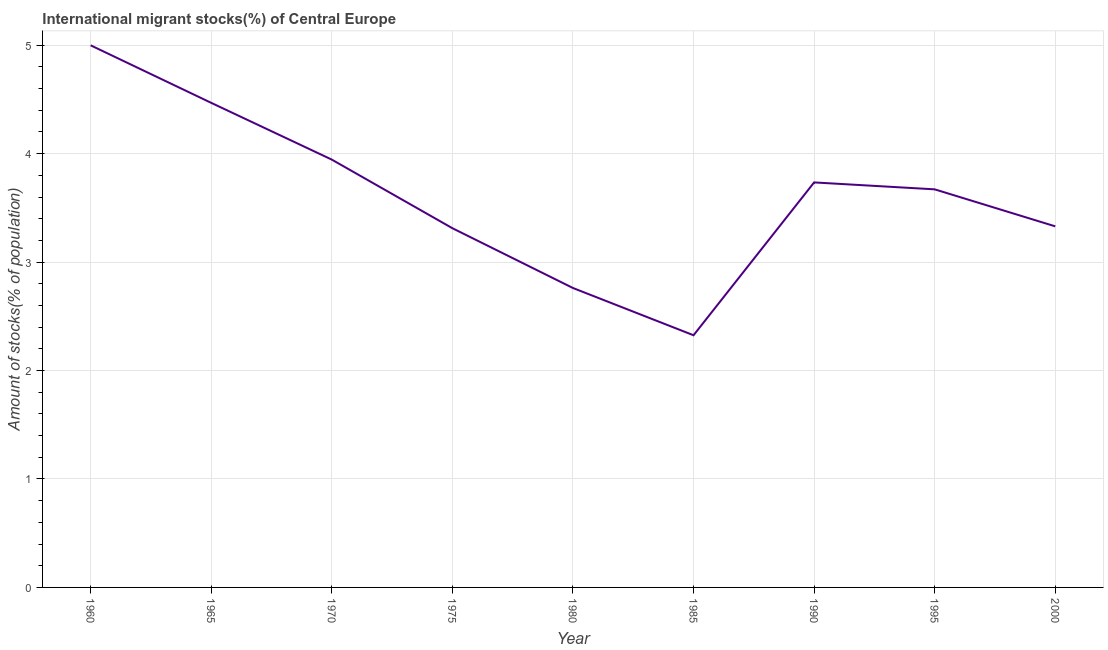What is the number of international migrant stocks in 1970?
Offer a very short reply. 3.95. Across all years, what is the maximum number of international migrant stocks?
Give a very brief answer. 5. Across all years, what is the minimum number of international migrant stocks?
Ensure brevity in your answer.  2.33. In which year was the number of international migrant stocks maximum?
Provide a short and direct response. 1960. What is the sum of the number of international migrant stocks?
Offer a terse response. 32.55. What is the difference between the number of international migrant stocks in 1980 and 1995?
Your answer should be compact. -0.91. What is the average number of international migrant stocks per year?
Keep it short and to the point. 3.62. What is the median number of international migrant stocks?
Offer a terse response. 3.67. In how many years, is the number of international migrant stocks greater than 0.2 %?
Your answer should be compact. 9. Do a majority of the years between 2000 and 1970 (inclusive) have number of international migrant stocks greater than 3.8 %?
Your answer should be compact. Yes. What is the ratio of the number of international migrant stocks in 1980 to that in 1995?
Provide a succinct answer. 0.75. What is the difference between the highest and the second highest number of international migrant stocks?
Ensure brevity in your answer.  0.53. Is the sum of the number of international migrant stocks in 1965 and 1995 greater than the maximum number of international migrant stocks across all years?
Offer a terse response. Yes. What is the difference between the highest and the lowest number of international migrant stocks?
Your response must be concise. 2.67. Does the number of international migrant stocks monotonically increase over the years?
Ensure brevity in your answer.  No. How many lines are there?
Offer a terse response. 1. How many years are there in the graph?
Your answer should be compact. 9. What is the difference between two consecutive major ticks on the Y-axis?
Provide a succinct answer. 1. Are the values on the major ticks of Y-axis written in scientific E-notation?
Give a very brief answer. No. Does the graph contain any zero values?
Provide a succinct answer. No. What is the title of the graph?
Offer a terse response. International migrant stocks(%) of Central Europe. What is the label or title of the X-axis?
Keep it short and to the point. Year. What is the label or title of the Y-axis?
Make the answer very short. Amount of stocks(% of population). What is the Amount of stocks(% of population) of 1960?
Keep it short and to the point. 5. What is the Amount of stocks(% of population) in 1965?
Give a very brief answer. 4.47. What is the Amount of stocks(% of population) in 1970?
Ensure brevity in your answer.  3.95. What is the Amount of stocks(% of population) in 1975?
Your answer should be compact. 3.31. What is the Amount of stocks(% of population) in 1980?
Offer a terse response. 2.76. What is the Amount of stocks(% of population) in 1985?
Offer a very short reply. 2.33. What is the Amount of stocks(% of population) of 1990?
Offer a terse response. 3.73. What is the Amount of stocks(% of population) in 1995?
Your answer should be very brief. 3.67. What is the Amount of stocks(% of population) in 2000?
Keep it short and to the point. 3.33. What is the difference between the Amount of stocks(% of population) in 1960 and 1965?
Offer a terse response. 0.53. What is the difference between the Amount of stocks(% of population) in 1960 and 1970?
Ensure brevity in your answer.  1.05. What is the difference between the Amount of stocks(% of population) in 1960 and 1975?
Your response must be concise. 1.69. What is the difference between the Amount of stocks(% of population) in 1960 and 1980?
Provide a succinct answer. 2.24. What is the difference between the Amount of stocks(% of population) in 1960 and 1985?
Provide a short and direct response. 2.67. What is the difference between the Amount of stocks(% of population) in 1960 and 1990?
Provide a succinct answer. 1.26. What is the difference between the Amount of stocks(% of population) in 1960 and 1995?
Your answer should be very brief. 1.33. What is the difference between the Amount of stocks(% of population) in 1960 and 2000?
Give a very brief answer. 1.67. What is the difference between the Amount of stocks(% of population) in 1965 and 1970?
Offer a very short reply. 0.52. What is the difference between the Amount of stocks(% of population) in 1965 and 1975?
Offer a very short reply. 1.16. What is the difference between the Amount of stocks(% of population) in 1965 and 1980?
Your response must be concise. 1.71. What is the difference between the Amount of stocks(% of population) in 1965 and 1985?
Offer a very short reply. 2.14. What is the difference between the Amount of stocks(% of population) in 1965 and 1990?
Your response must be concise. 0.73. What is the difference between the Amount of stocks(% of population) in 1965 and 1995?
Provide a short and direct response. 0.8. What is the difference between the Amount of stocks(% of population) in 1965 and 2000?
Offer a very short reply. 1.14. What is the difference between the Amount of stocks(% of population) in 1970 and 1975?
Offer a very short reply. 0.63. What is the difference between the Amount of stocks(% of population) in 1970 and 1980?
Make the answer very short. 1.18. What is the difference between the Amount of stocks(% of population) in 1970 and 1985?
Your answer should be compact. 1.62. What is the difference between the Amount of stocks(% of population) in 1970 and 1990?
Your answer should be very brief. 0.21. What is the difference between the Amount of stocks(% of population) in 1970 and 1995?
Your answer should be very brief. 0.27. What is the difference between the Amount of stocks(% of population) in 1970 and 2000?
Your response must be concise. 0.62. What is the difference between the Amount of stocks(% of population) in 1975 and 1980?
Your answer should be very brief. 0.55. What is the difference between the Amount of stocks(% of population) in 1975 and 1985?
Provide a succinct answer. 0.99. What is the difference between the Amount of stocks(% of population) in 1975 and 1990?
Offer a very short reply. -0.42. What is the difference between the Amount of stocks(% of population) in 1975 and 1995?
Give a very brief answer. -0.36. What is the difference between the Amount of stocks(% of population) in 1975 and 2000?
Your response must be concise. -0.02. What is the difference between the Amount of stocks(% of population) in 1980 and 1985?
Your answer should be very brief. 0.44. What is the difference between the Amount of stocks(% of population) in 1980 and 1990?
Your answer should be compact. -0.97. What is the difference between the Amount of stocks(% of population) in 1980 and 1995?
Offer a very short reply. -0.91. What is the difference between the Amount of stocks(% of population) in 1980 and 2000?
Ensure brevity in your answer.  -0.57. What is the difference between the Amount of stocks(% of population) in 1985 and 1990?
Ensure brevity in your answer.  -1.41. What is the difference between the Amount of stocks(% of population) in 1985 and 1995?
Provide a succinct answer. -1.35. What is the difference between the Amount of stocks(% of population) in 1985 and 2000?
Your answer should be very brief. -1. What is the difference between the Amount of stocks(% of population) in 1990 and 1995?
Offer a terse response. 0.06. What is the difference between the Amount of stocks(% of population) in 1990 and 2000?
Your answer should be compact. 0.41. What is the difference between the Amount of stocks(% of population) in 1995 and 2000?
Your answer should be compact. 0.34. What is the ratio of the Amount of stocks(% of population) in 1960 to that in 1965?
Give a very brief answer. 1.12. What is the ratio of the Amount of stocks(% of population) in 1960 to that in 1970?
Your response must be concise. 1.27. What is the ratio of the Amount of stocks(% of population) in 1960 to that in 1975?
Offer a terse response. 1.51. What is the ratio of the Amount of stocks(% of population) in 1960 to that in 1980?
Give a very brief answer. 1.81. What is the ratio of the Amount of stocks(% of population) in 1960 to that in 1985?
Provide a succinct answer. 2.15. What is the ratio of the Amount of stocks(% of population) in 1960 to that in 1990?
Offer a terse response. 1.34. What is the ratio of the Amount of stocks(% of population) in 1960 to that in 1995?
Your answer should be compact. 1.36. What is the ratio of the Amount of stocks(% of population) in 1960 to that in 2000?
Your answer should be very brief. 1.5. What is the ratio of the Amount of stocks(% of population) in 1965 to that in 1970?
Provide a succinct answer. 1.13. What is the ratio of the Amount of stocks(% of population) in 1965 to that in 1975?
Offer a terse response. 1.35. What is the ratio of the Amount of stocks(% of population) in 1965 to that in 1980?
Ensure brevity in your answer.  1.62. What is the ratio of the Amount of stocks(% of population) in 1965 to that in 1985?
Give a very brief answer. 1.92. What is the ratio of the Amount of stocks(% of population) in 1965 to that in 1990?
Ensure brevity in your answer.  1.2. What is the ratio of the Amount of stocks(% of population) in 1965 to that in 1995?
Keep it short and to the point. 1.22. What is the ratio of the Amount of stocks(% of population) in 1965 to that in 2000?
Keep it short and to the point. 1.34. What is the ratio of the Amount of stocks(% of population) in 1970 to that in 1975?
Your answer should be compact. 1.19. What is the ratio of the Amount of stocks(% of population) in 1970 to that in 1980?
Keep it short and to the point. 1.43. What is the ratio of the Amount of stocks(% of population) in 1970 to that in 1985?
Give a very brief answer. 1.7. What is the ratio of the Amount of stocks(% of population) in 1970 to that in 1990?
Ensure brevity in your answer.  1.06. What is the ratio of the Amount of stocks(% of population) in 1970 to that in 1995?
Your response must be concise. 1.07. What is the ratio of the Amount of stocks(% of population) in 1970 to that in 2000?
Your response must be concise. 1.19. What is the ratio of the Amount of stocks(% of population) in 1975 to that in 1980?
Give a very brief answer. 1.2. What is the ratio of the Amount of stocks(% of population) in 1975 to that in 1985?
Provide a short and direct response. 1.42. What is the ratio of the Amount of stocks(% of population) in 1975 to that in 1990?
Your response must be concise. 0.89. What is the ratio of the Amount of stocks(% of population) in 1975 to that in 1995?
Keep it short and to the point. 0.9. What is the ratio of the Amount of stocks(% of population) in 1980 to that in 1985?
Offer a very short reply. 1.19. What is the ratio of the Amount of stocks(% of population) in 1980 to that in 1990?
Your answer should be very brief. 0.74. What is the ratio of the Amount of stocks(% of population) in 1980 to that in 1995?
Offer a very short reply. 0.75. What is the ratio of the Amount of stocks(% of population) in 1980 to that in 2000?
Provide a short and direct response. 0.83. What is the ratio of the Amount of stocks(% of population) in 1985 to that in 1990?
Your response must be concise. 0.62. What is the ratio of the Amount of stocks(% of population) in 1985 to that in 1995?
Give a very brief answer. 0.63. What is the ratio of the Amount of stocks(% of population) in 1985 to that in 2000?
Keep it short and to the point. 0.7. What is the ratio of the Amount of stocks(% of population) in 1990 to that in 2000?
Offer a very short reply. 1.12. What is the ratio of the Amount of stocks(% of population) in 1995 to that in 2000?
Your answer should be compact. 1.1. 